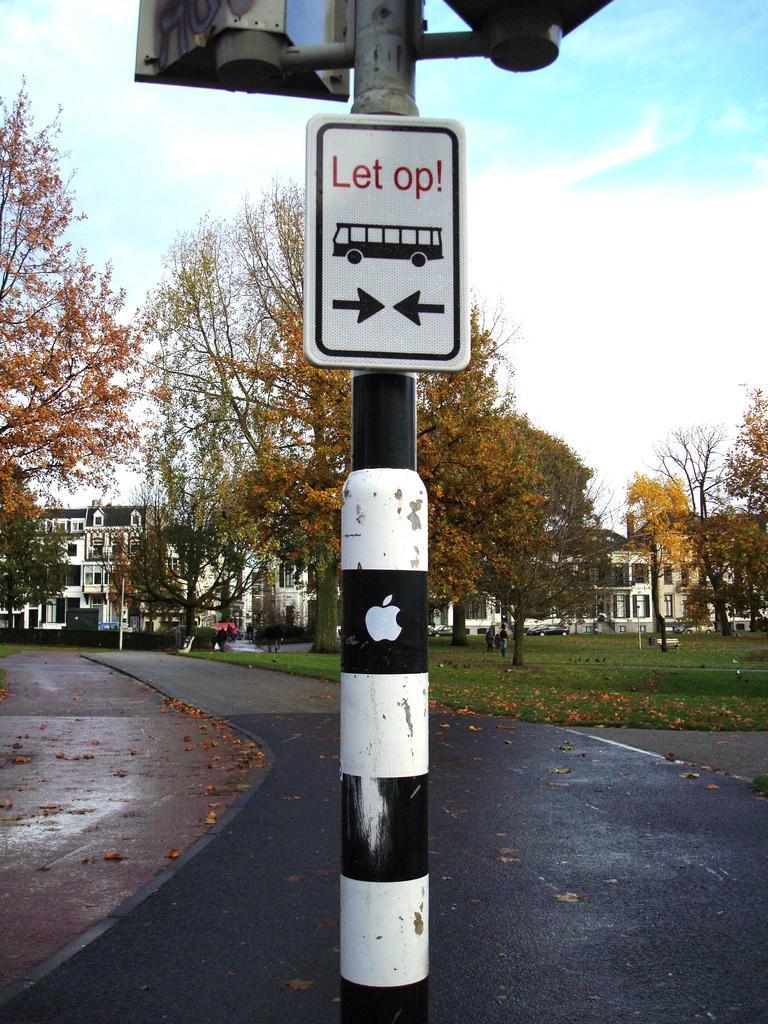Please provide a concise description of this image. In this picture we can see traffic signs attached to a pole with an apple symbol on it, dried leaves on the road, grass, trees, buildings and some people and in the background we can see the sky with clouds. 